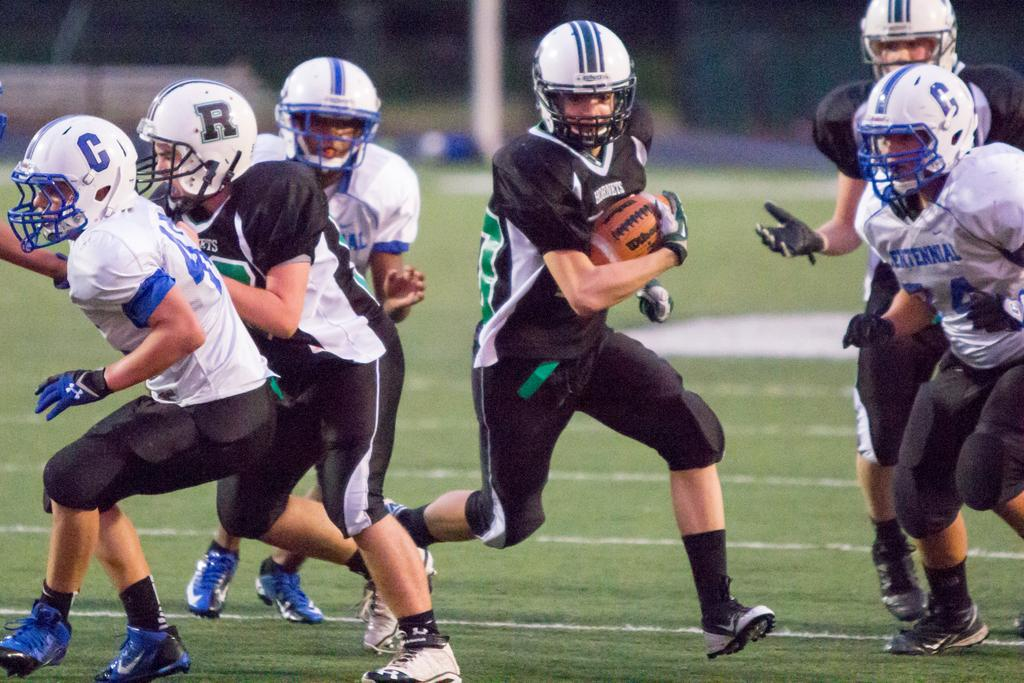How many people are in the image? There is a group of people in the image. What are the people wearing on their heads? The people are wearing helmets. What object is one person holding? One person is holding a ball. Can you describe the background of the image? The background of the image is blurry. What type of soda can be seen in the image? There is no soda present in the image. How many dimes are visible on the ground in the image? There are no dimes visible in the image. 